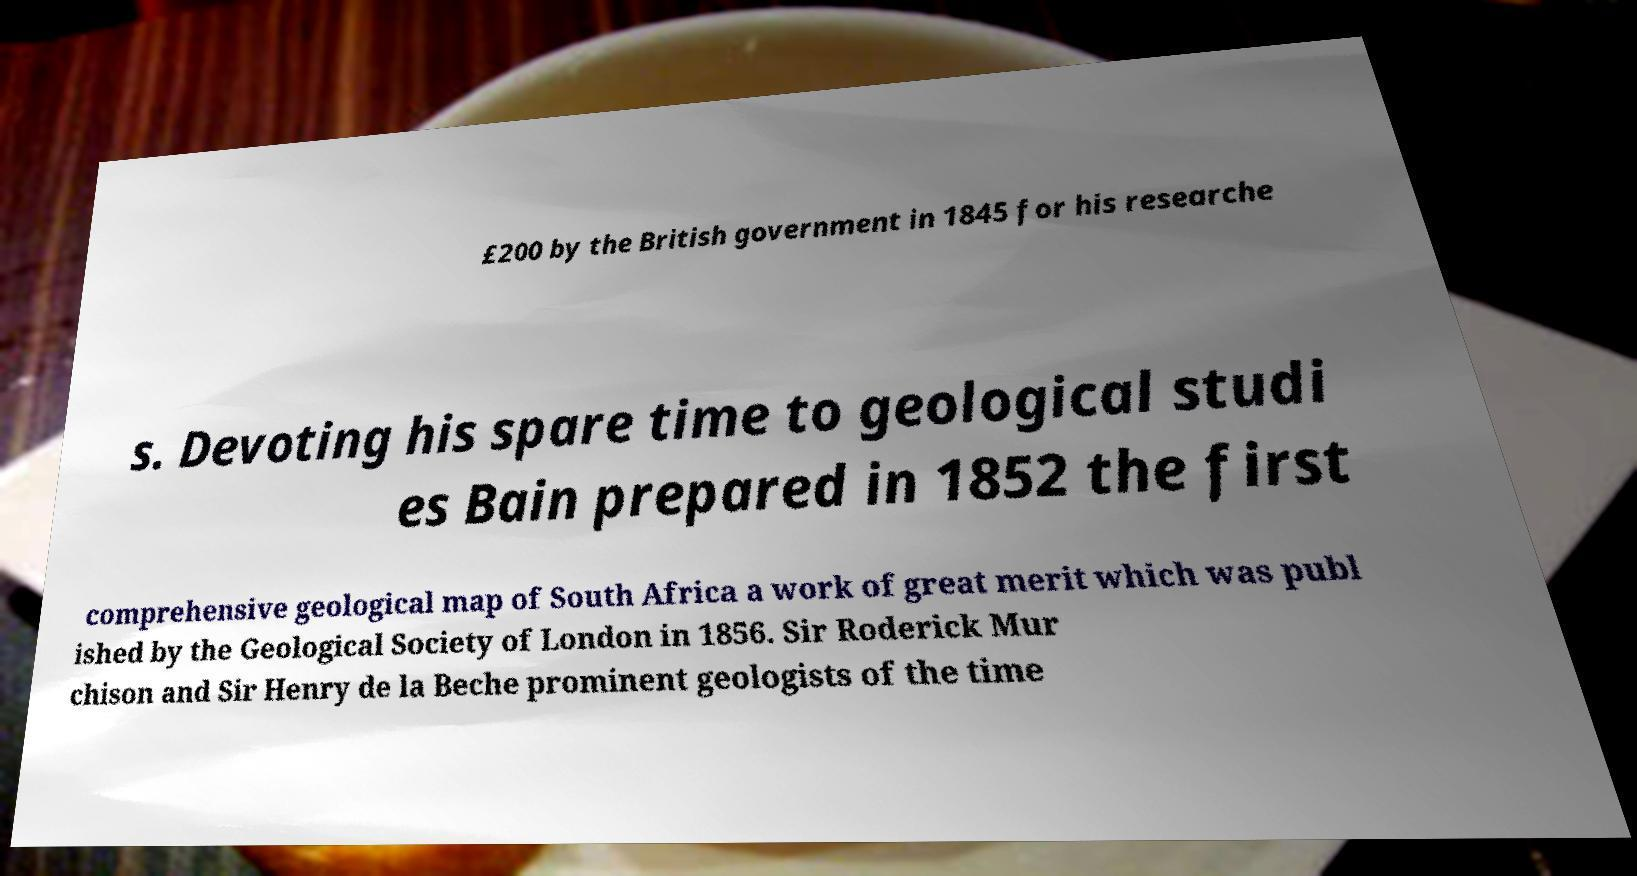Can you read and provide the text displayed in the image?This photo seems to have some interesting text. Can you extract and type it out for me? £200 by the British government in 1845 for his researche s. Devoting his spare time to geological studi es Bain prepared in 1852 the first comprehensive geological map of South Africa a work of great merit which was publ ished by the Geological Society of London in 1856. Sir Roderick Mur chison and Sir Henry de la Beche prominent geologists of the time 